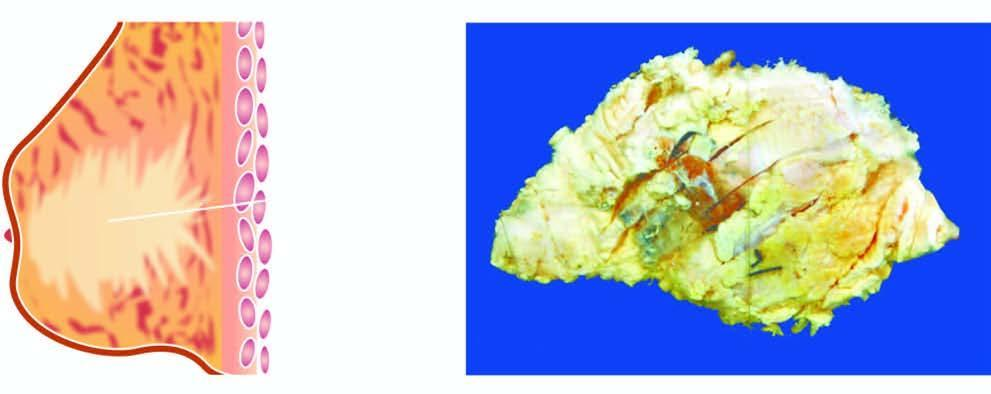what does cut surface show?
Answer the question using a single word or phrase. A grey white firm tumour extending irregularly into adjacent breast parenchyma 